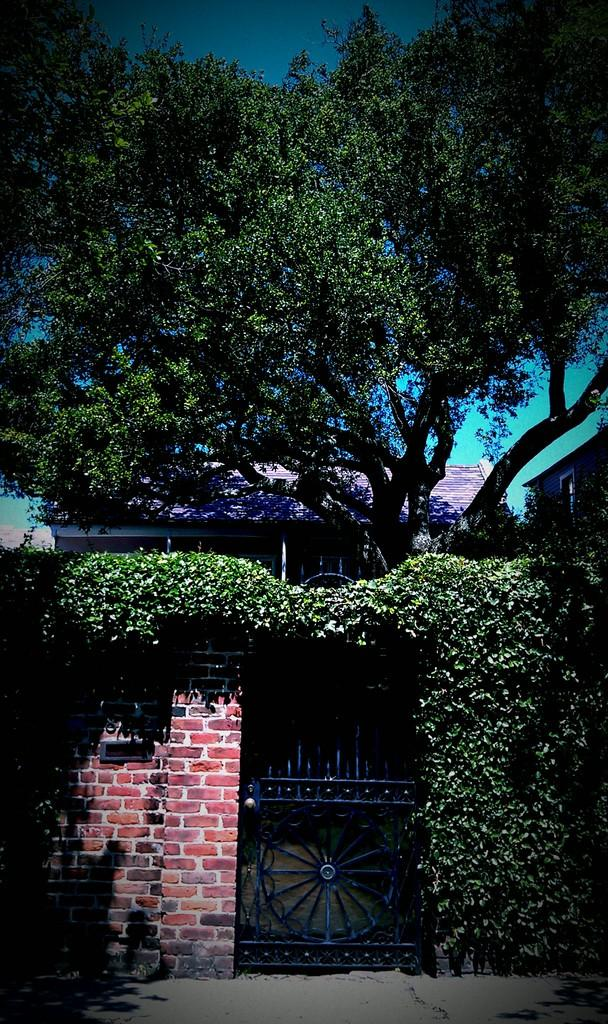What type of structures are present in the image? There are buildings in the image. What is located in front of the building? There is a tree, a wall, a gate, and plants in front of the building. What can be seen at the top of the image? The sky is visible at the top of the image. What type of agreement did the dad sign with the wrench in the image? There is no dad, agreement, or wrench present in the image. 